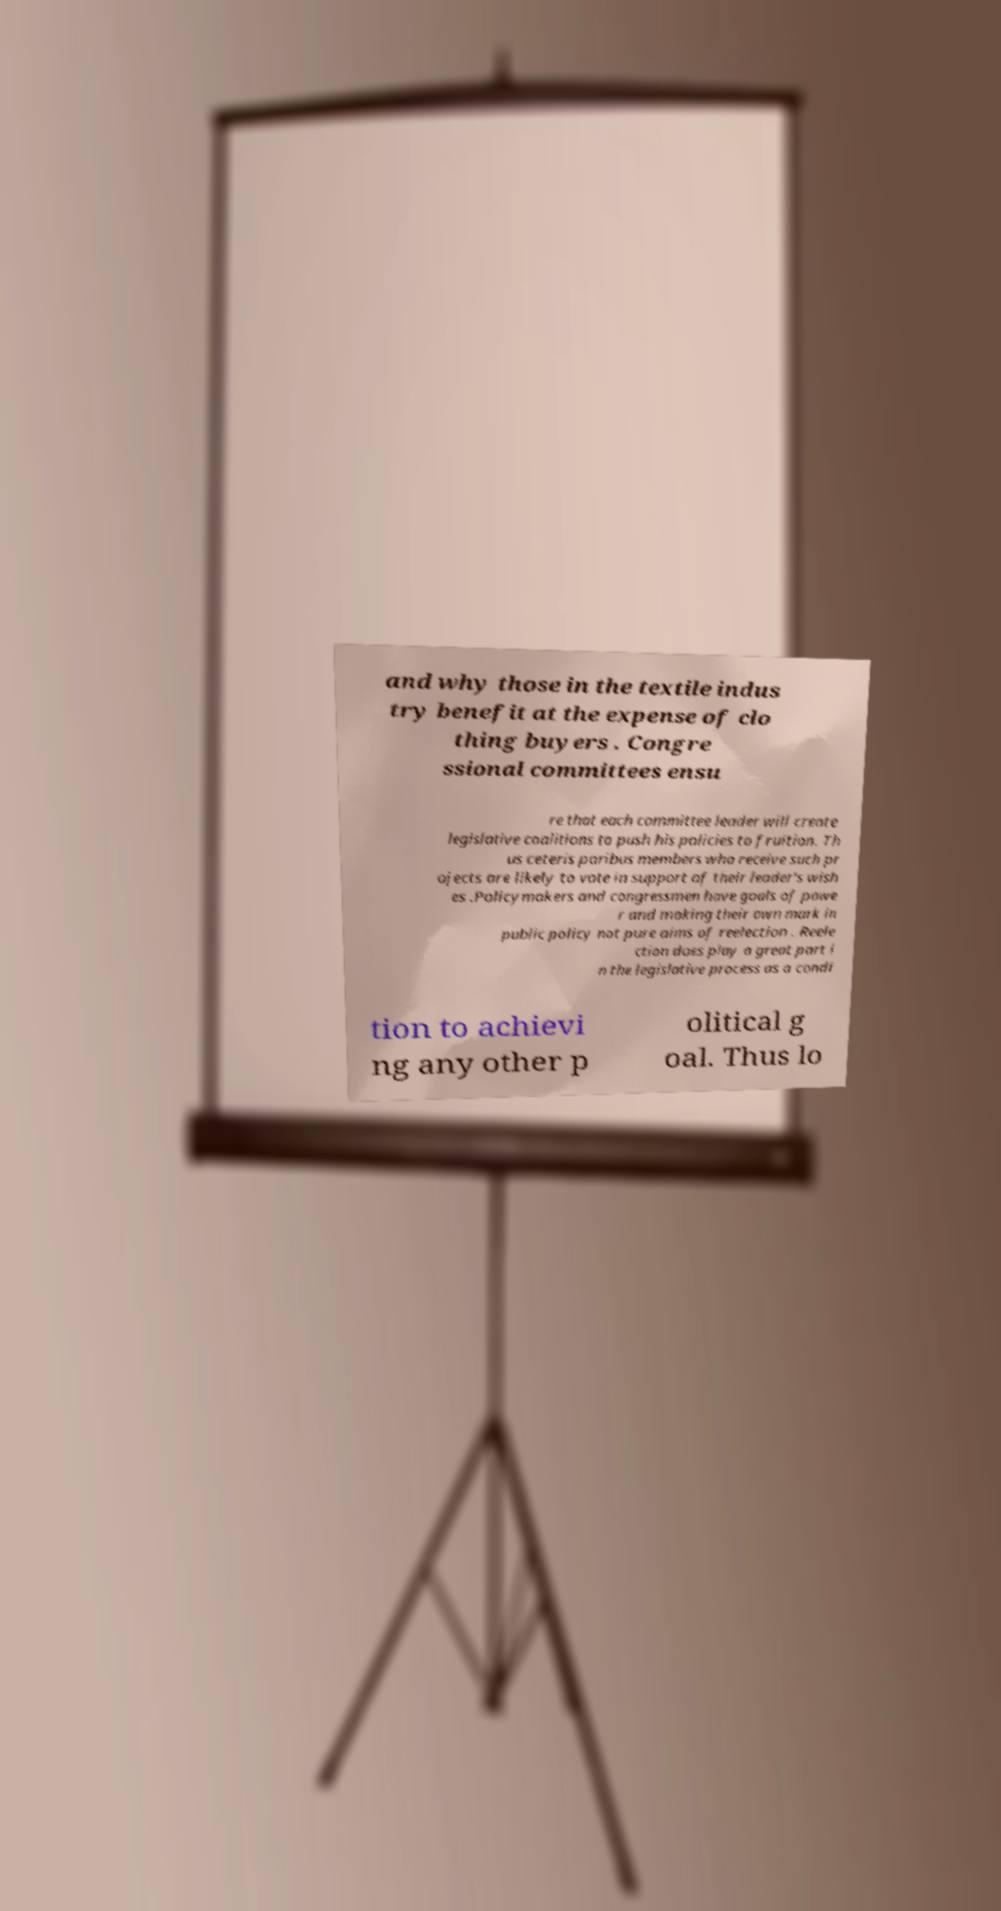Please read and relay the text visible in this image. What does it say? and why those in the textile indus try benefit at the expense of clo thing buyers . Congre ssional committees ensu re that each committee leader will create legislative coalitions to push his policies to fruition. Th us ceteris paribus members who receive such pr ojects are likely to vote in support of their leader's wish es .Policymakers and congressmen have goals of powe r and making their own mark in public policy not pure aims of reelection . Reele ction does play a great part i n the legislative process as a condi tion to achievi ng any other p olitical g oal. Thus lo 